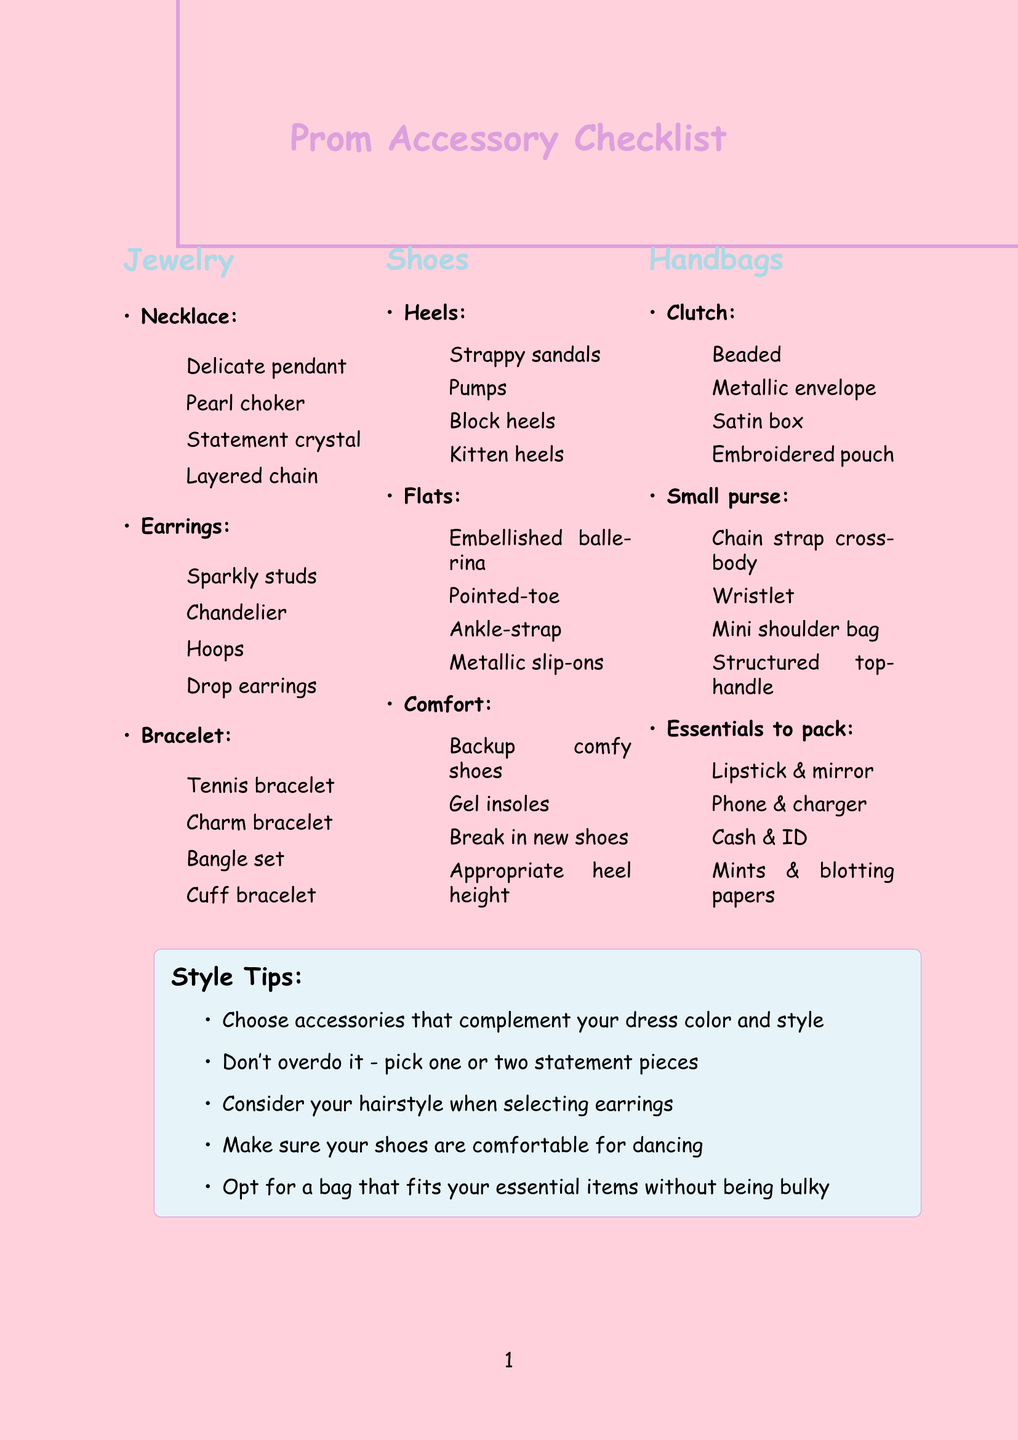What are the options for necklaces? The options for necklaces include delicate pendant necklace, pearl choker, statement crystal necklace, and layered chain necklace.
Answer: Delicate pendant necklace, pearl choker, statement crystal necklace, layered chain necklace How many types of earrings are listed? The earrings listed include four different types. Counting those, there are sparkly studs, chandelier earrings, hoops, and drop earrings.
Answer: 4 Name one type of heel mentioned. The document lists various types of heels, including strappy sandals, pumps, block heels, and kitten heels.
Answer: Strappy sandals What should you consider when choosing earrings? One consideration offered is how your hairstyle will affect earring choice. It emphasizes selecting earrings that pair well with your hairstyle.
Answer: Hairstyle What essentials should be packed in a handbag? The essentials to pack include lipstick and compact mirror, phone and portable charger, cash and ID, and breath mints and blotting papers.
Answer: Lipstick and compact mirror, phone and portable charger, cash and ID, breath mints and blotting papers What is one style tip mentioned? Among the style tips, one suggests selecting accessories that match the dress color and style, highlighting the importance of coordination.
Answer: Choose accessories that complement your dress color and style Which budget tip encourages versatility? One budget tip mentions investing in versatile pieces, suggesting that items can be reused for different occasions.
Answer: Invest in versatile pieces you can wear again for other occasions List a type of flat shoe included in the document. The document describes four types of flats, including embellished ballerina flats, pointed-toe flats, ankle-strap flats, and metallic slip-ons.
Answer: Embellished ballerina flats 